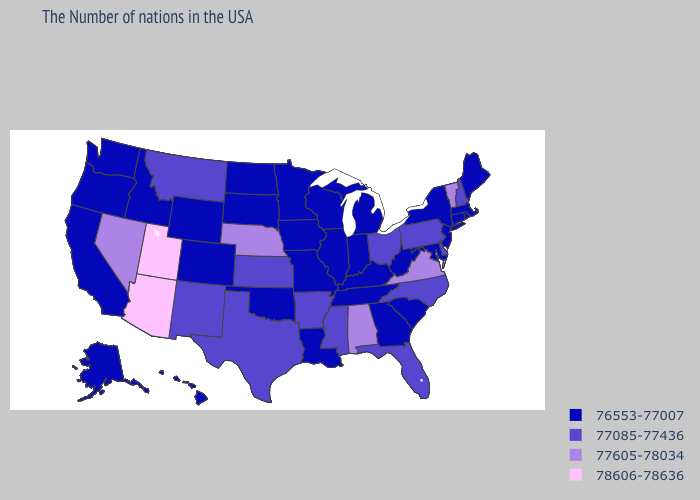What is the value of Utah?
Keep it brief. 78606-78636. Does New Hampshire have the highest value in the USA?
Write a very short answer. No. Does the map have missing data?
Answer briefly. No. Name the states that have a value in the range 77605-78034?
Write a very short answer. Vermont, Virginia, Alabama, Nebraska, Nevada. What is the value of Maryland?
Give a very brief answer. 76553-77007. Does the map have missing data?
Write a very short answer. No. Does Ohio have the lowest value in the MidWest?
Keep it brief. No. Which states have the highest value in the USA?
Give a very brief answer. Utah, Arizona. What is the value of Illinois?
Give a very brief answer. 76553-77007. Among the states that border Georgia , does Alabama have the highest value?
Keep it brief. Yes. Name the states that have a value in the range 77085-77436?
Short answer required. New Hampshire, Delaware, Pennsylvania, North Carolina, Ohio, Florida, Mississippi, Arkansas, Kansas, Texas, New Mexico, Montana. Name the states that have a value in the range 76553-77007?
Write a very short answer. Maine, Massachusetts, Rhode Island, Connecticut, New York, New Jersey, Maryland, South Carolina, West Virginia, Georgia, Michigan, Kentucky, Indiana, Tennessee, Wisconsin, Illinois, Louisiana, Missouri, Minnesota, Iowa, Oklahoma, South Dakota, North Dakota, Wyoming, Colorado, Idaho, California, Washington, Oregon, Alaska, Hawaii. How many symbols are there in the legend?
Concise answer only. 4. Which states have the lowest value in the USA?
Write a very short answer. Maine, Massachusetts, Rhode Island, Connecticut, New York, New Jersey, Maryland, South Carolina, West Virginia, Georgia, Michigan, Kentucky, Indiana, Tennessee, Wisconsin, Illinois, Louisiana, Missouri, Minnesota, Iowa, Oklahoma, South Dakota, North Dakota, Wyoming, Colorado, Idaho, California, Washington, Oregon, Alaska, Hawaii. Name the states that have a value in the range 76553-77007?
Concise answer only. Maine, Massachusetts, Rhode Island, Connecticut, New York, New Jersey, Maryland, South Carolina, West Virginia, Georgia, Michigan, Kentucky, Indiana, Tennessee, Wisconsin, Illinois, Louisiana, Missouri, Minnesota, Iowa, Oklahoma, South Dakota, North Dakota, Wyoming, Colorado, Idaho, California, Washington, Oregon, Alaska, Hawaii. 